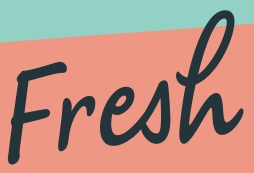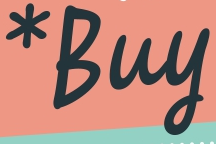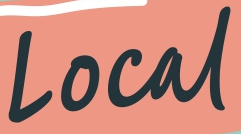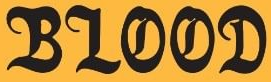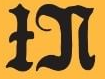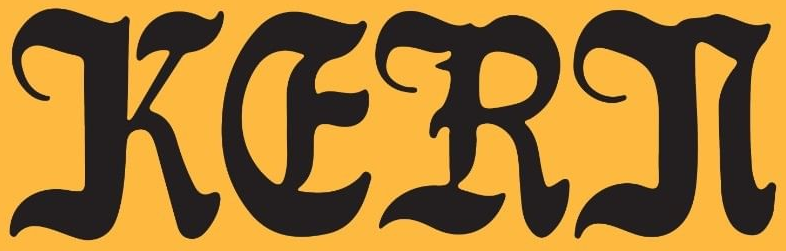Read the text content from these images in order, separated by a semicolon. Fresh; *Buy; Local; BLOOD; IN; KERN 